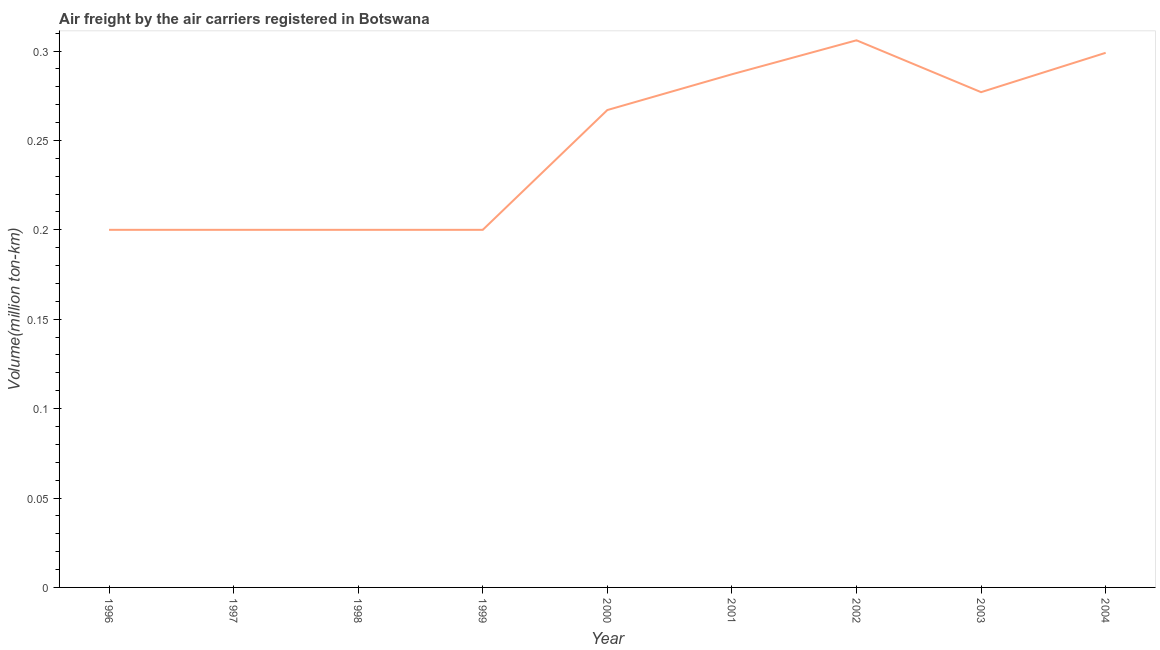What is the air freight in 1999?
Ensure brevity in your answer.  0.2. Across all years, what is the maximum air freight?
Ensure brevity in your answer.  0.31. Across all years, what is the minimum air freight?
Your answer should be compact. 0.2. What is the sum of the air freight?
Your answer should be compact. 2.24. What is the difference between the air freight in 1999 and 2003?
Offer a terse response. -0.08. What is the average air freight per year?
Make the answer very short. 0.25. What is the median air freight?
Offer a terse response. 0.27. In how many years, is the air freight greater than 0.21000000000000002 million ton-km?
Your response must be concise. 5. Do a majority of the years between 1998 and 2004 (inclusive) have air freight greater than 0.2 million ton-km?
Provide a succinct answer. Yes. What is the ratio of the air freight in 1999 to that in 2000?
Ensure brevity in your answer.  0.75. Is the difference between the air freight in 2000 and 2003 greater than the difference between any two years?
Ensure brevity in your answer.  No. What is the difference between the highest and the second highest air freight?
Keep it short and to the point. 0.01. Is the sum of the air freight in 1997 and 2003 greater than the maximum air freight across all years?
Give a very brief answer. Yes. What is the difference between the highest and the lowest air freight?
Make the answer very short. 0.11. What is the title of the graph?
Your answer should be very brief. Air freight by the air carriers registered in Botswana. What is the label or title of the X-axis?
Offer a very short reply. Year. What is the label or title of the Y-axis?
Offer a very short reply. Volume(million ton-km). What is the Volume(million ton-km) in 1996?
Provide a succinct answer. 0.2. What is the Volume(million ton-km) in 1997?
Make the answer very short. 0.2. What is the Volume(million ton-km) of 1998?
Offer a very short reply. 0.2. What is the Volume(million ton-km) in 1999?
Your answer should be compact. 0.2. What is the Volume(million ton-km) in 2000?
Offer a very short reply. 0.27. What is the Volume(million ton-km) of 2001?
Your response must be concise. 0.29. What is the Volume(million ton-km) in 2002?
Provide a succinct answer. 0.31. What is the Volume(million ton-km) of 2003?
Offer a terse response. 0.28. What is the Volume(million ton-km) in 2004?
Your answer should be compact. 0.3. What is the difference between the Volume(million ton-km) in 1996 and 1997?
Ensure brevity in your answer.  0. What is the difference between the Volume(million ton-km) in 1996 and 2000?
Ensure brevity in your answer.  -0.07. What is the difference between the Volume(million ton-km) in 1996 and 2001?
Provide a short and direct response. -0.09. What is the difference between the Volume(million ton-km) in 1996 and 2002?
Provide a short and direct response. -0.11. What is the difference between the Volume(million ton-km) in 1996 and 2003?
Provide a succinct answer. -0.08. What is the difference between the Volume(million ton-km) in 1996 and 2004?
Provide a succinct answer. -0.1. What is the difference between the Volume(million ton-km) in 1997 and 1998?
Your response must be concise. 0. What is the difference between the Volume(million ton-km) in 1997 and 2000?
Offer a very short reply. -0.07. What is the difference between the Volume(million ton-km) in 1997 and 2001?
Give a very brief answer. -0.09. What is the difference between the Volume(million ton-km) in 1997 and 2002?
Provide a succinct answer. -0.11. What is the difference between the Volume(million ton-km) in 1997 and 2003?
Ensure brevity in your answer.  -0.08. What is the difference between the Volume(million ton-km) in 1997 and 2004?
Make the answer very short. -0.1. What is the difference between the Volume(million ton-km) in 1998 and 2000?
Provide a succinct answer. -0.07. What is the difference between the Volume(million ton-km) in 1998 and 2001?
Keep it short and to the point. -0.09. What is the difference between the Volume(million ton-km) in 1998 and 2002?
Give a very brief answer. -0.11. What is the difference between the Volume(million ton-km) in 1998 and 2003?
Ensure brevity in your answer.  -0.08. What is the difference between the Volume(million ton-km) in 1998 and 2004?
Your answer should be compact. -0.1. What is the difference between the Volume(million ton-km) in 1999 and 2000?
Provide a short and direct response. -0.07. What is the difference between the Volume(million ton-km) in 1999 and 2001?
Offer a terse response. -0.09. What is the difference between the Volume(million ton-km) in 1999 and 2002?
Keep it short and to the point. -0.11. What is the difference between the Volume(million ton-km) in 1999 and 2003?
Keep it short and to the point. -0.08. What is the difference between the Volume(million ton-km) in 1999 and 2004?
Give a very brief answer. -0.1. What is the difference between the Volume(million ton-km) in 2000 and 2001?
Keep it short and to the point. -0.02. What is the difference between the Volume(million ton-km) in 2000 and 2002?
Provide a short and direct response. -0.04. What is the difference between the Volume(million ton-km) in 2000 and 2003?
Make the answer very short. -0.01. What is the difference between the Volume(million ton-km) in 2000 and 2004?
Provide a succinct answer. -0.03. What is the difference between the Volume(million ton-km) in 2001 and 2002?
Your answer should be very brief. -0.02. What is the difference between the Volume(million ton-km) in 2001 and 2004?
Your response must be concise. -0.01. What is the difference between the Volume(million ton-km) in 2002 and 2003?
Make the answer very short. 0.03. What is the difference between the Volume(million ton-km) in 2002 and 2004?
Your answer should be compact. 0.01. What is the difference between the Volume(million ton-km) in 2003 and 2004?
Your answer should be very brief. -0.02. What is the ratio of the Volume(million ton-km) in 1996 to that in 2000?
Offer a very short reply. 0.75. What is the ratio of the Volume(million ton-km) in 1996 to that in 2001?
Give a very brief answer. 0.7. What is the ratio of the Volume(million ton-km) in 1996 to that in 2002?
Provide a succinct answer. 0.65. What is the ratio of the Volume(million ton-km) in 1996 to that in 2003?
Make the answer very short. 0.72. What is the ratio of the Volume(million ton-km) in 1996 to that in 2004?
Provide a succinct answer. 0.67. What is the ratio of the Volume(million ton-km) in 1997 to that in 1998?
Your answer should be very brief. 1. What is the ratio of the Volume(million ton-km) in 1997 to that in 1999?
Give a very brief answer. 1. What is the ratio of the Volume(million ton-km) in 1997 to that in 2000?
Provide a short and direct response. 0.75. What is the ratio of the Volume(million ton-km) in 1997 to that in 2001?
Keep it short and to the point. 0.7. What is the ratio of the Volume(million ton-km) in 1997 to that in 2002?
Your answer should be very brief. 0.65. What is the ratio of the Volume(million ton-km) in 1997 to that in 2003?
Ensure brevity in your answer.  0.72. What is the ratio of the Volume(million ton-km) in 1997 to that in 2004?
Provide a succinct answer. 0.67. What is the ratio of the Volume(million ton-km) in 1998 to that in 2000?
Your answer should be compact. 0.75. What is the ratio of the Volume(million ton-km) in 1998 to that in 2001?
Your response must be concise. 0.7. What is the ratio of the Volume(million ton-km) in 1998 to that in 2002?
Offer a very short reply. 0.65. What is the ratio of the Volume(million ton-km) in 1998 to that in 2003?
Give a very brief answer. 0.72. What is the ratio of the Volume(million ton-km) in 1998 to that in 2004?
Your response must be concise. 0.67. What is the ratio of the Volume(million ton-km) in 1999 to that in 2000?
Offer a terse response. 0.75. What is the ratio of the Volume(million ton-km) in 1999 to that in 2001?
Make the answer very short. 0.7. What is the ratio of the Volume(million ton-km) in 1999 to that in 2002?
Keep it short and to the point. 0.65. What is the ratio of the Volume(million ton-km) in 1999 to that in 2003?
Keep it short and to the point. 0.72. What is the ratio of the Volume(million ton-km) in 1999 to that in 2004?
Give a very brief answer. 0.67. What is the ratio of the Volume(million ton-km) in 2000 to that in 2002?
Make the answer very short. 0.87. What is the ratio of the Volume(million ton-km) in 2000 to that in 2003?
Provide a succinct answer. 0.96. What is the ratio of the Volume(million ton-km) in 2000 to that in 2004?
Offer a very short reply. 0.89. What is the ratio of the Volume(million ton-km) in 2001 to that in 2002?
Your response must be concise. 0.94. What is the ratio of the Volume(million ton-km) in 2001 to that in 2003?
Give a very brief answer. 1.04. What is the ratio of the Volume(million ton-km) in 2002 to that in 2003?
Make the answer very short. 1.1. What is the ratio of the Volume(million ton-km) in 2002 to that in 2004?
Your answer should be very brief. 1.02. What is the ratio of the Volume(million ton-km) in 2003 to that in 2004?
Give a very brief answer. 0.93. 